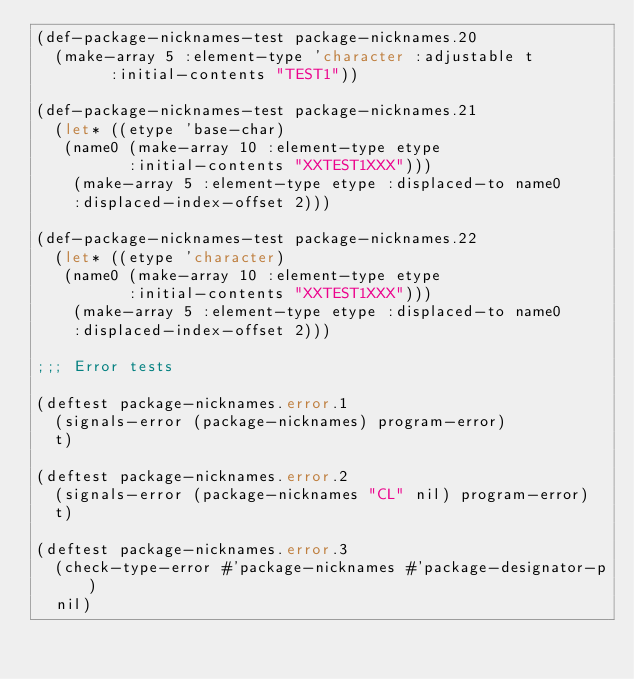Convert code to text. <code><loc_0><loc_0><loc_500><loc_500><_Lisp_>(def-package-nicknames-test package-nicknames.20
  (make-array 5 :element-type 'character :adjustable t
	      :initial-contents "TEST1"))

(def-package-nicknames-test package-nicknames.21
  (let* ((etype 'base-char)
	 (name0 (make-array 10 :element-type etype
			    :initial-contents "XXTEST1XXX")))
    (make-array 5 :element-type etype :displaced-to name0
		:displaced-index-offset 2)))

(def-package-nicknames-test package-nicknames.22
  (let* ((etype 'character)
	 (name0 (make-array 10 :element-type etype
			    :initial-contents "XXTEST1XXX")))
    (make-array 5 :element-type etype :displaced-to name0
		:displaced-index-offset 2)))

;;; Error tests

(deftest package-nicknames.error.1
  (signals-error (package-nicknames) program-error)
  t)

(deftest package-nicknames.error.2
  (signals-error (package-nicknames "CL" nil) program-error)
  t)

(deftest package-nicknames.error.3
  (check-type-error #'package-nicknames #'package-designator-p)
  nil)

</code> 